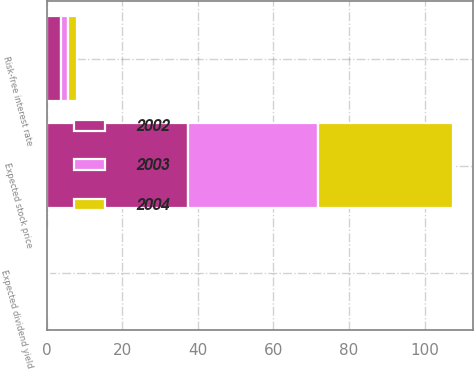<chart> <loc_0><loc_0><loc_500><loc_500><stacked_bar_chart><ecel><fcel>Risk-free interest rate<fcel>Expected dividend yield<fcel>Expected stock price<nl><fcel>2003<fcel>1.94<fcel>0.19<fcel>34.3<nl><fcel>2004<fcel>2.27<fcel>0.18<fcel>35.8<nl><fcel>2002<fcel>3.76<fcel>0.18<fcel>37.4<nl></chart> 